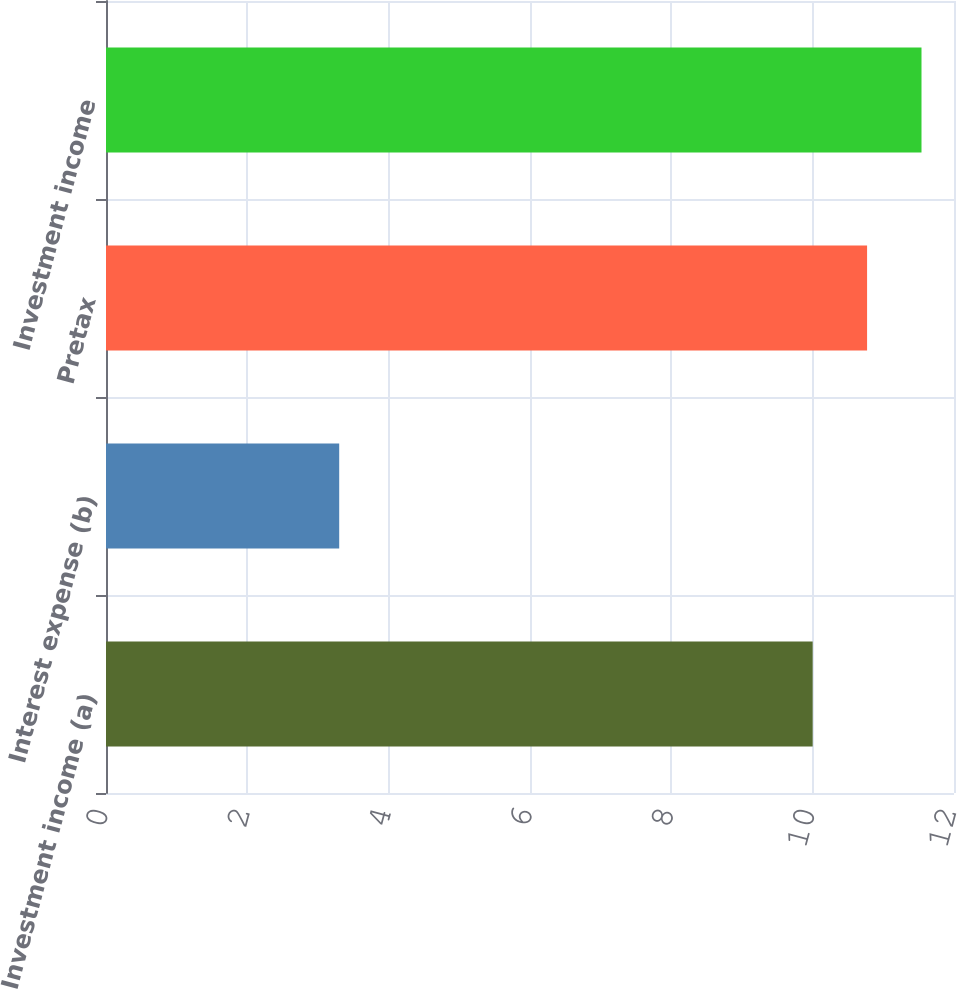Convert chart. <chart><loc_0><loc_0><loc_500><loc_500><bar_chart><fcel>Investment income (a)<fcel>Interest expense (b)<fcel>Pretax<fcel>Investment income<nl><fcel>10<fcel>3.3<fcel>10.77<fcel>11.54<nl></chart> 